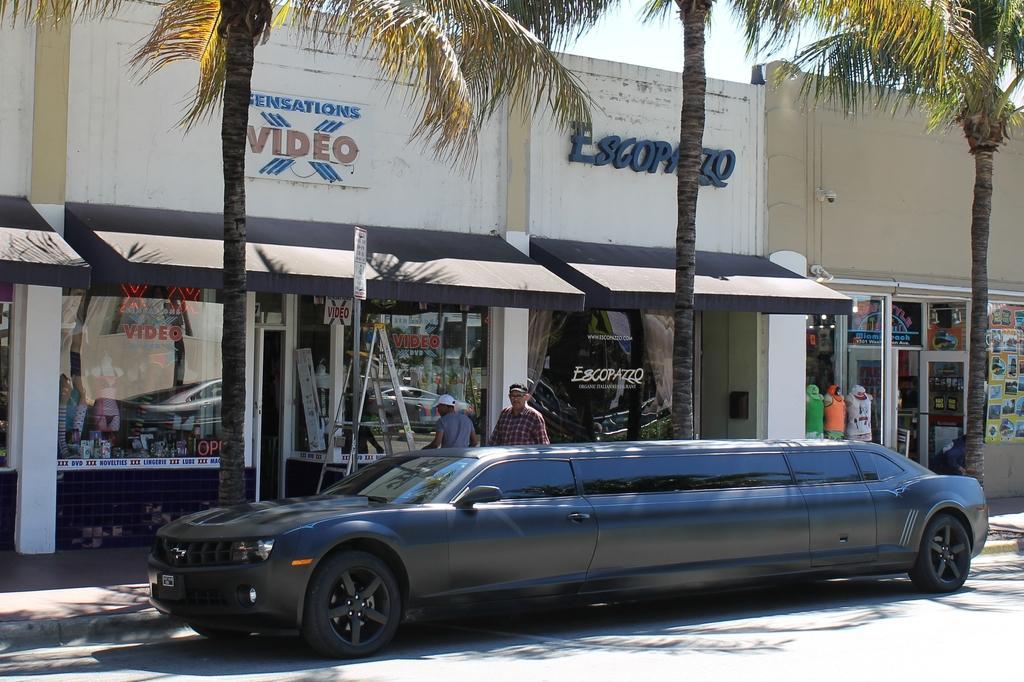Please provide a concise description of this image. In in the picture I can see a car on the road which is dark in color. In the background I can see buildings, trees, people, framed glass wall and some other objects. I can also see the sky in the background. 